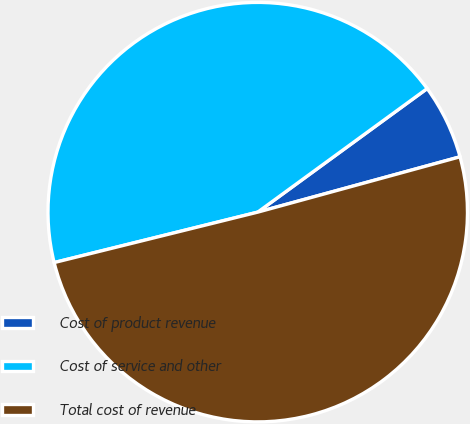<chart> <loc_0><loc_0><loc_500><loc_500><pie_chart><fcel>Cost of product revenue<fcel>Cost of service and other<fcel>Total cost of revenue<nl><fcel>5.78%<fcel>43.84%<fcel>50.39%<nl></chart> 